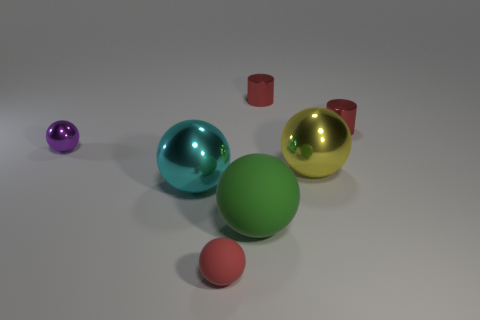Does the ball that is in front of the big green thing have the same material as the tiny purple sphere?
Provide a succinct answer. No. What is the shape of the tiny red shiny thing that is on the left side of the yellow thing?
Your answer should be compact. Cylinder. What number of other purple balls have the same size as the purple ball?
Provide a succinct answer. 0. What is the size of the yellow shiny object?
Make the answer very short. Large. There is a large cyan metal ball; what number of big objects are in front of it?
Offer a very short reply. 1. There is a object that is made of the same material as the green ball; what is its shape?
Your answer should be very brief. Sphere. Are there fewer big yellow balls that are behind the big yellow sphere than tiny red spheres right of the big green matte sphere?
Make the answer very short. No. Is the number of spheres greater than the number of red things?
Ensure brevity in your answer.  Yes. What is the material of the yellow thing?
Keep it short and to the point. Metal. There is a tiny thing that is in front of the large green rubber object; what is its color?
Your answer should be very brief. Red. 